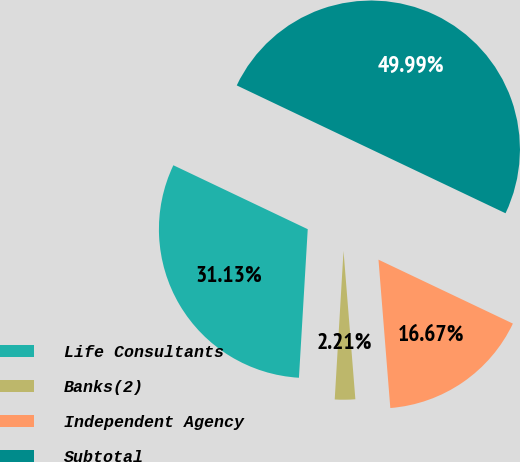Convert chart. <chart><loc_0><loc_0><loc_500><loc_500><pie_chart><fcel>Life Consultants<fcel>Banks(2)<fcel>Independent Agency<fcel>Subtotal<nl><fcel>31.13%<fcel>2.21%<fcel>16.67%<fcel>50.0%<nl></chart> 